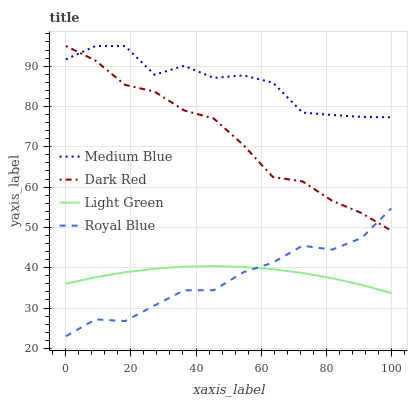Does Royal Blue have the minimum area under the curve?
Answer yes or no. Yes. Does Medium Blue have the maximum area under the curve?
Answer yes or no. Yes. Does Light Green have the minimum area under the curve?
Answer yes or no. No. Does Light Green have the maximum area under the curve?
Answer yes or no. No. Is Light Green the smoothest?
Answer yes or no. Yes. Is Medium Blue the roughest?
Answer yes or no. Yes. Is Medium Blue the smoothest?
Answer yes or no. No. Is Light Green the roughest?
Answer yes or no. No. Does Royal Blue have the lowest value?
Answer yes or no. Yes. Does Light Green have the lowest value?
Answer yes or no. No. Does Medium Blue have the highest value?
Answer yes or no. Yes. Does Light Green have the highest value?
Answer yes or no. No. Is Light Green less than Medium Blue?
Answer yes or no. Yes. Is Dark Red greater than Light Green?
Answer yes or no. Yes. Does Royal Blue intersect Light Green?
Answer yes or no. Yes. Is Royal Blue less than Light Green?
Answer yes or no. No. Is Royal Blue greater than Light Green?
Answer yes or no. No. Does Light Green intersect Medium Blue?
Answer yes or no. No. 